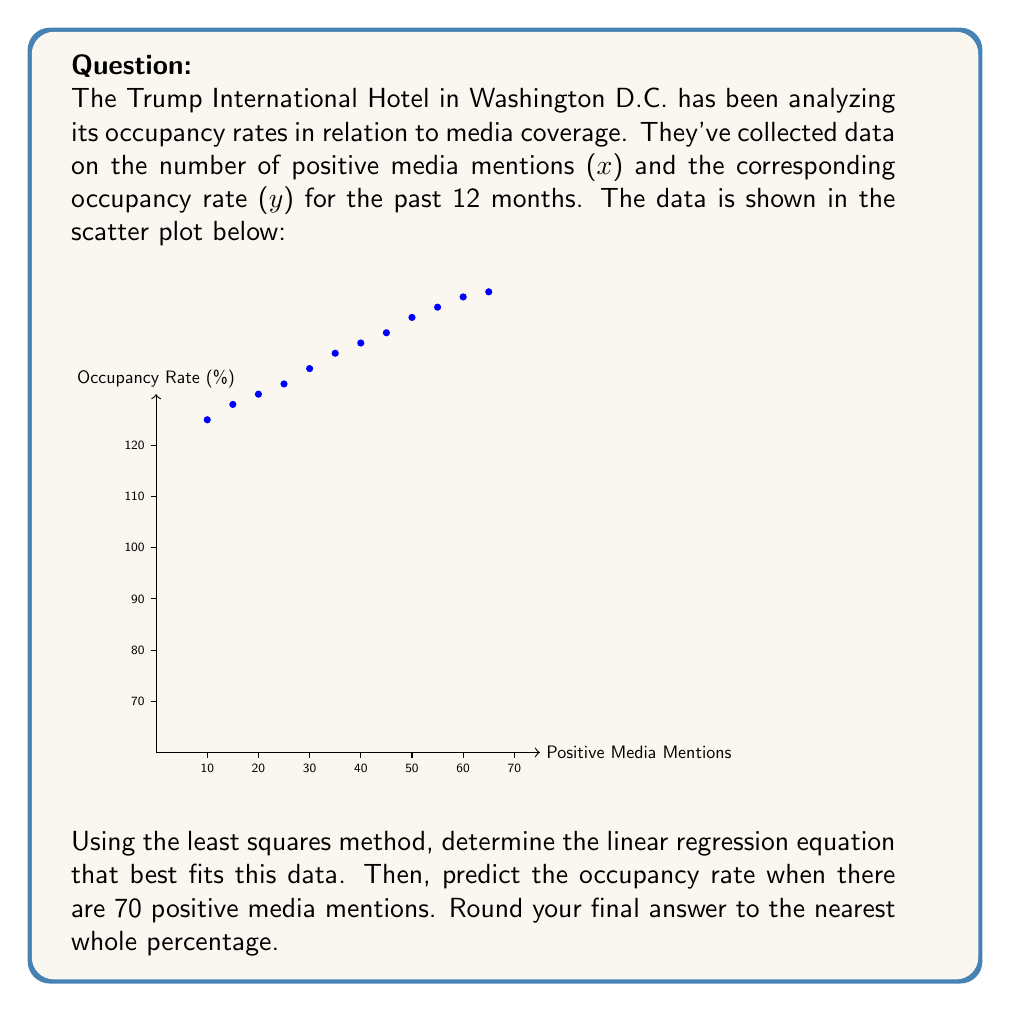Can you solve this math problem? To solve this problem, we'll follow these steps:

1) First, we need to calculate the following sums:
   $$\sum x, \sum y, \sum xy, \sum x^2$$

2) We can use these formulas for the slope (m) and y-intercept (b):
   $$m = \frac{n\sum xy - \sum x \sum y}{n\sum x^2 - (\sum x)^2}$$
   $$b = \frac{\sum y - m\sum x}{n}$$
   where n is the number of data points (12 in this case)

3) Calculating the sums:
   $$\sum x = 450$$
   $$\sum y = 941$$
   $$\sum xy = 37,525$$
   $$\sum x^2 = 18,750$$

4) Plugging into the formulas:
   $$m = \frac{12(37,525) - 450(941)}{12(18,750) - 450^2} = 0.4545$$
   $$b = \frac{941 - 0.4545(450)}{12} = 60.23$$

5) Our linear regression equation is:
   $$y = 0.4545x + 60.23$$

6) To predict the occupancy rate for 70 positive mentions, we substitute x = 70:
   $$y = 0.4545(70) + 60.23 = 92.045$$

7) Rounding to the nearest whole percentage:
   $$y \approx 92\%$$
Answer: 92% 